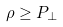<formula> <loc_0><loc_0><loc_500><loc_500>\rho \geq P _ { \bot }</formula> 